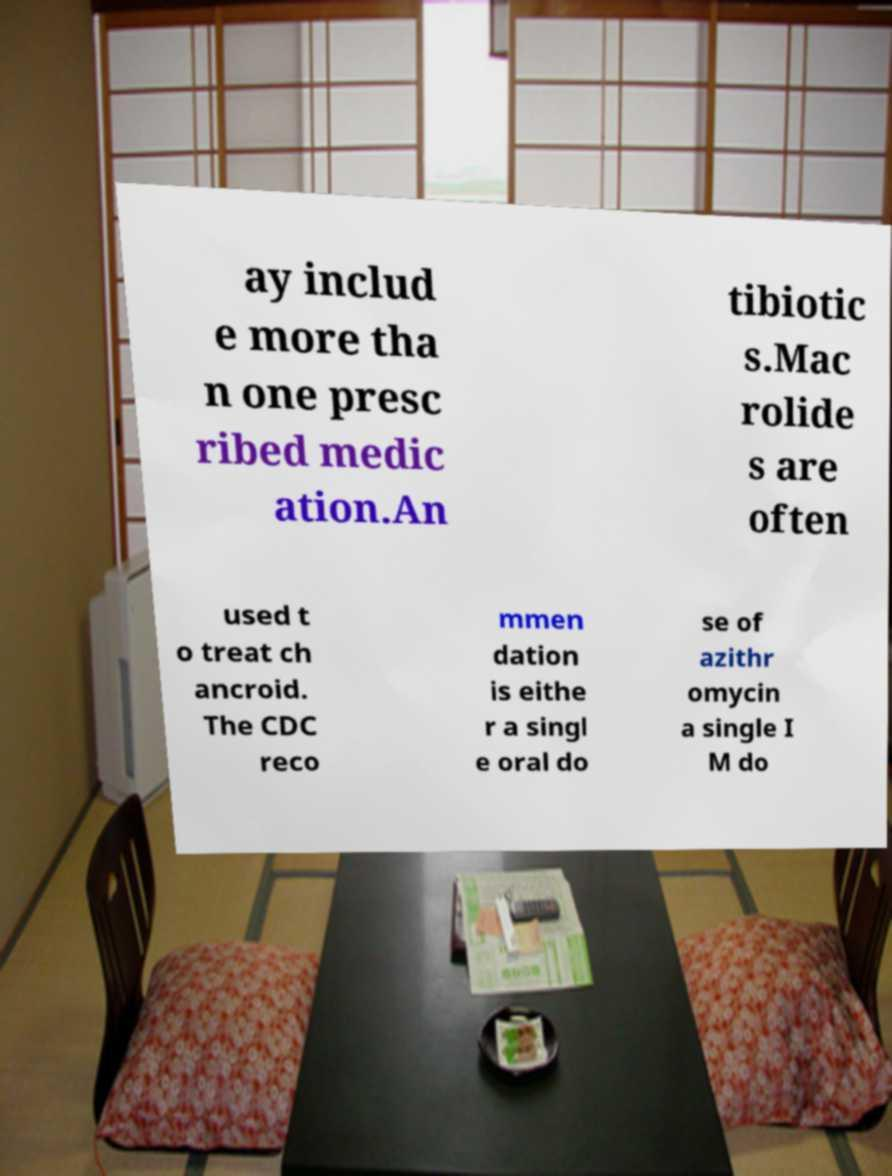Can you accurately transcribe the text from the provided image for me? ay includ e more tha n one presc ribed medic ation.An tibiotic s.Mac rolide s are often used t o treat ch ancroid. The CDC reco mmen dation is eithe r a singl e oral do se of azithr omycin a single I M do 